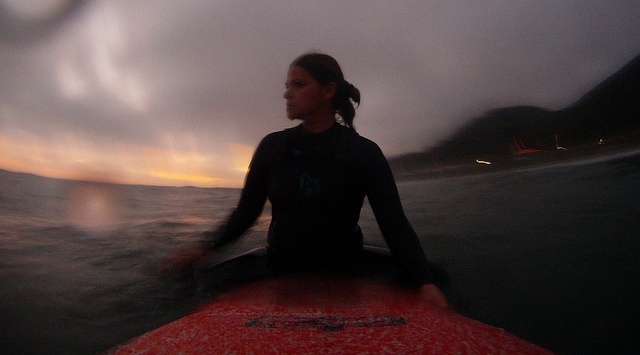Describe the objects in this image and their specific colors. I can see people in gray, black, maroon, and brown tones and surfboard in gray, maroon, black, and brown tones in this image. 